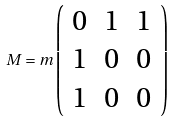<formula> <loc_0><loc_0><loc_500><loc_500>M = m \left ( \begin{array} { c c c } { 0 } & { 1 } & { 1 } \\ { 1 } & { 0 } & { 0 } \\ { 1 } & { 0 } & { 0 } \end{array} \right )</formula> 